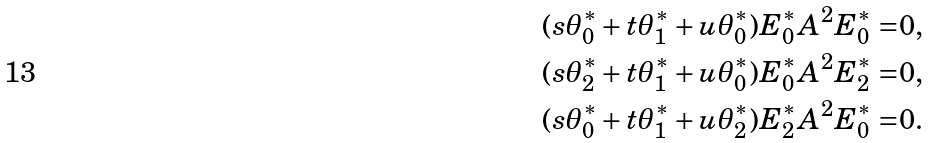Convert formula to latex. <formula><loc_0><loc_0><loc_500><loc_500>( s \theta _ { 0 } ^ { * } + t \theta _ { 1 } ^ { * } + u \theta _ { 0 } ^ { * } ) E _ { 0 } ^ { * } A ^ { 2 } E _ { 0 } ^ { * } = & 0 , \\ ( s \theta _ { 2 } ^ { * } + t \theta _ { 1 } ^ { * } + u \theta _ { 0 } ^ { * } ) E _ { 0 } ^ { * } A ^ { 2 } E _ { 2 } ^ { * } = & 0 , \\ ( s \theta _ { 0 } ^ { * } + t \theta _ { 1 } ^ { * } + u \theta _ { 2 } ^ { * } ) E _ { 2 } ^ { * } A ^ { 2 } E _ { 0 } ^ { * } = & 0 .</formula> 